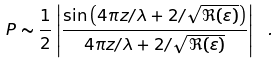Convert formula to latex. <formula><loc_0><loc_0><loc_500><loc_500>P \sim \frac { 1 } { 2 } \left | \frac { \sin \left ( 4 \pi z / \lambda + 2 / \sqrt { \Re ( \varepsilon ) } \right ) } { 4 \pi z / \lambda + 2 / \sqrt { \Re ( \varepsilon ) } } \right | \ .</formula> 